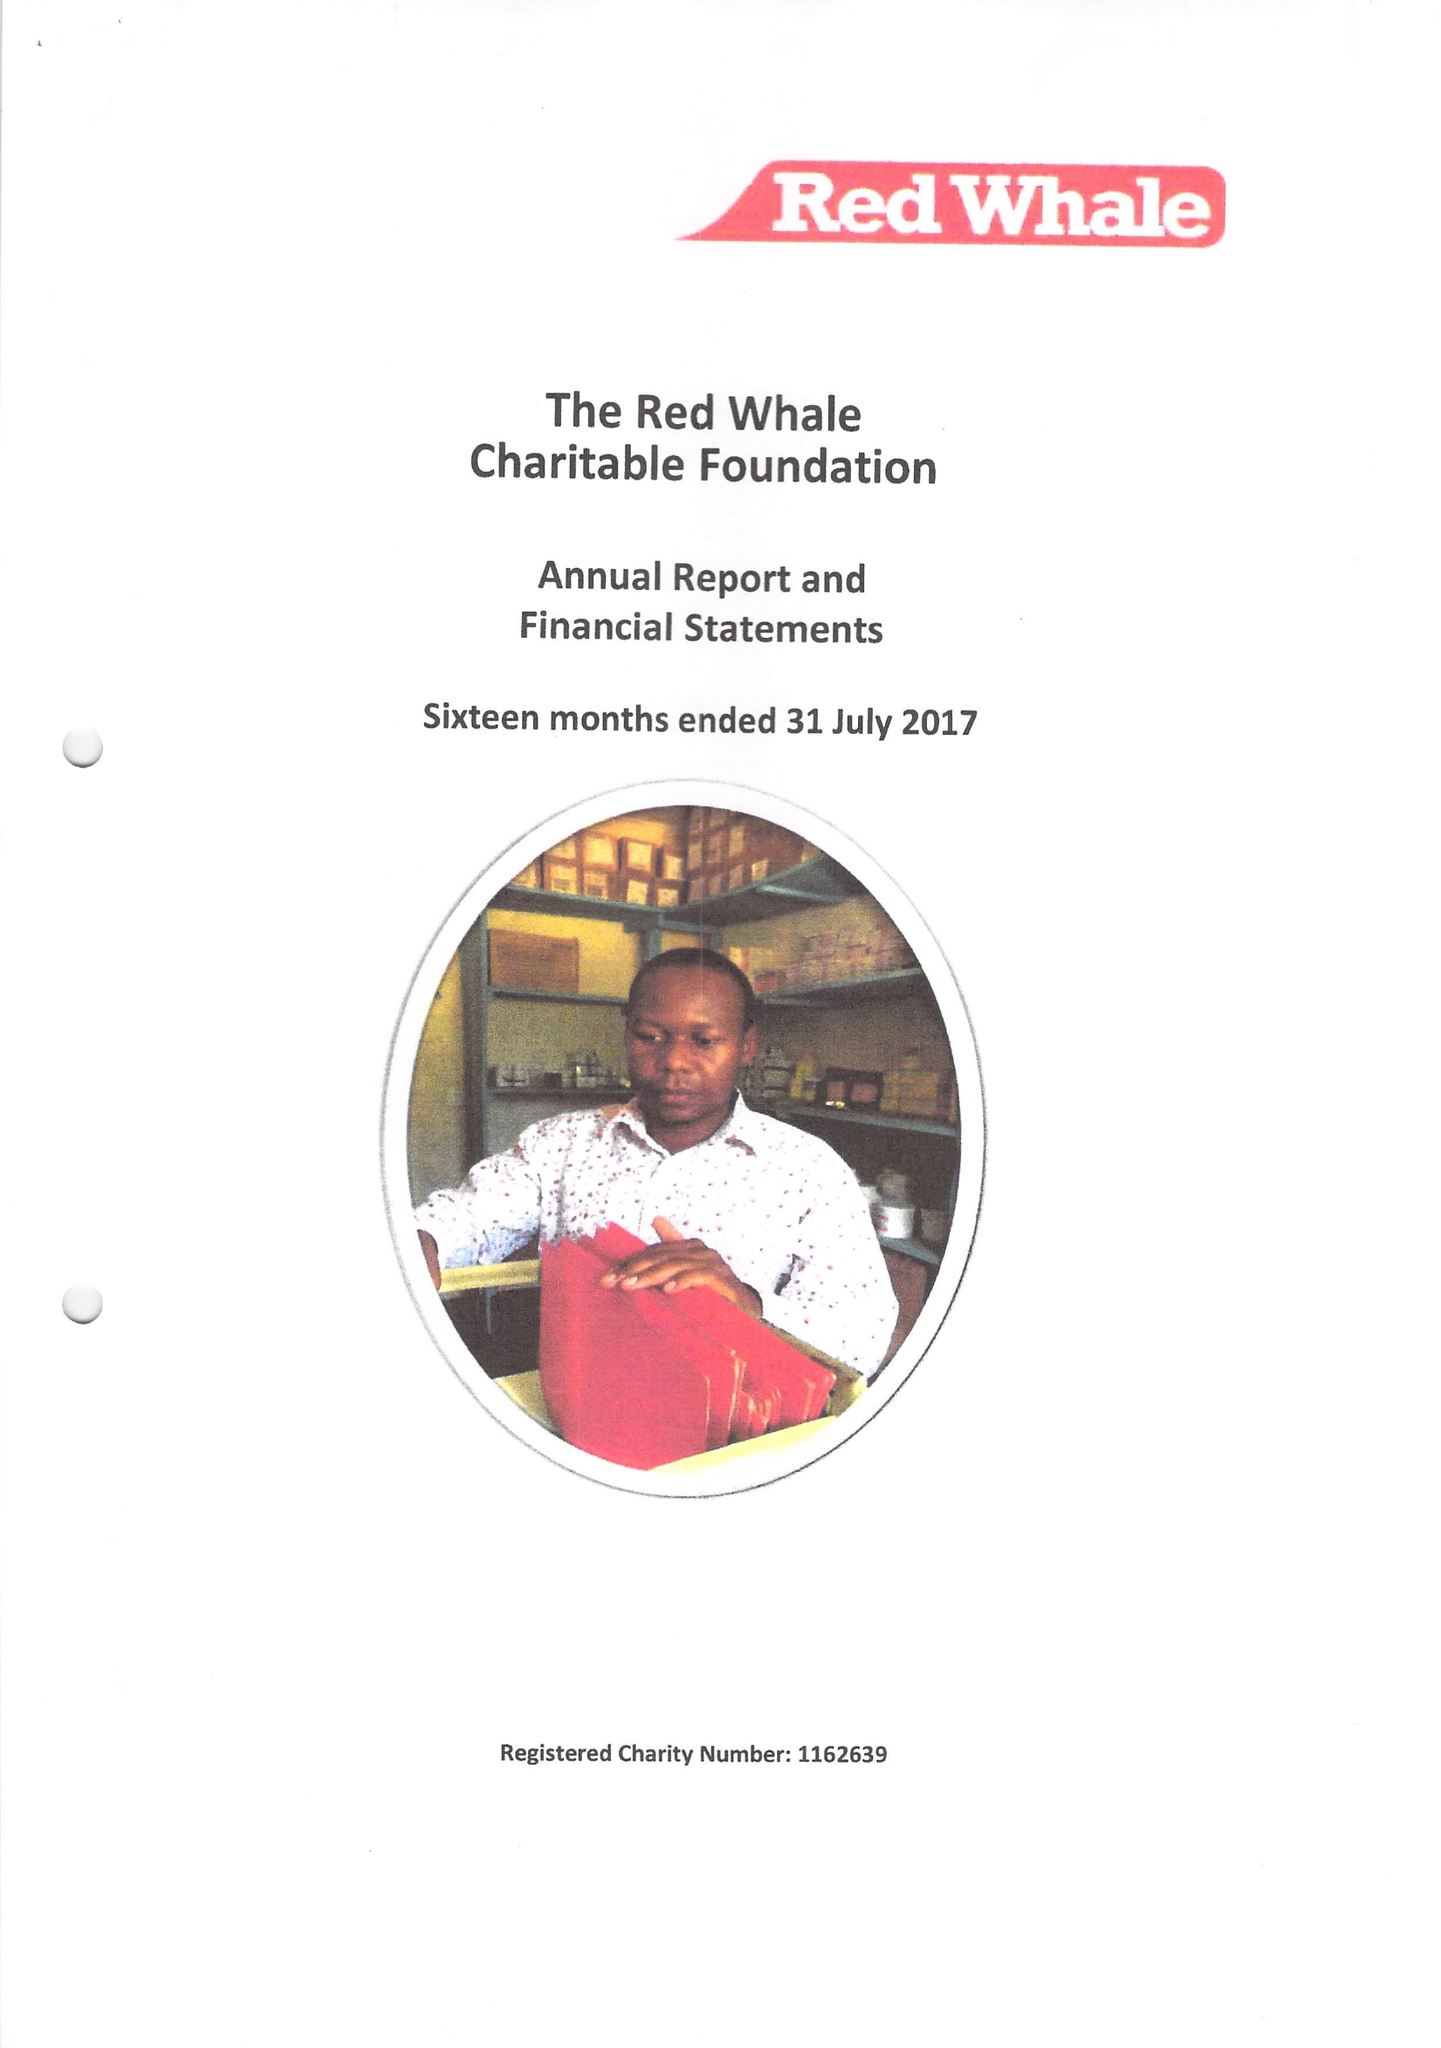What is the value for the income_annually_in_british_pounds?
Answer the question using a single word or phrase. None 